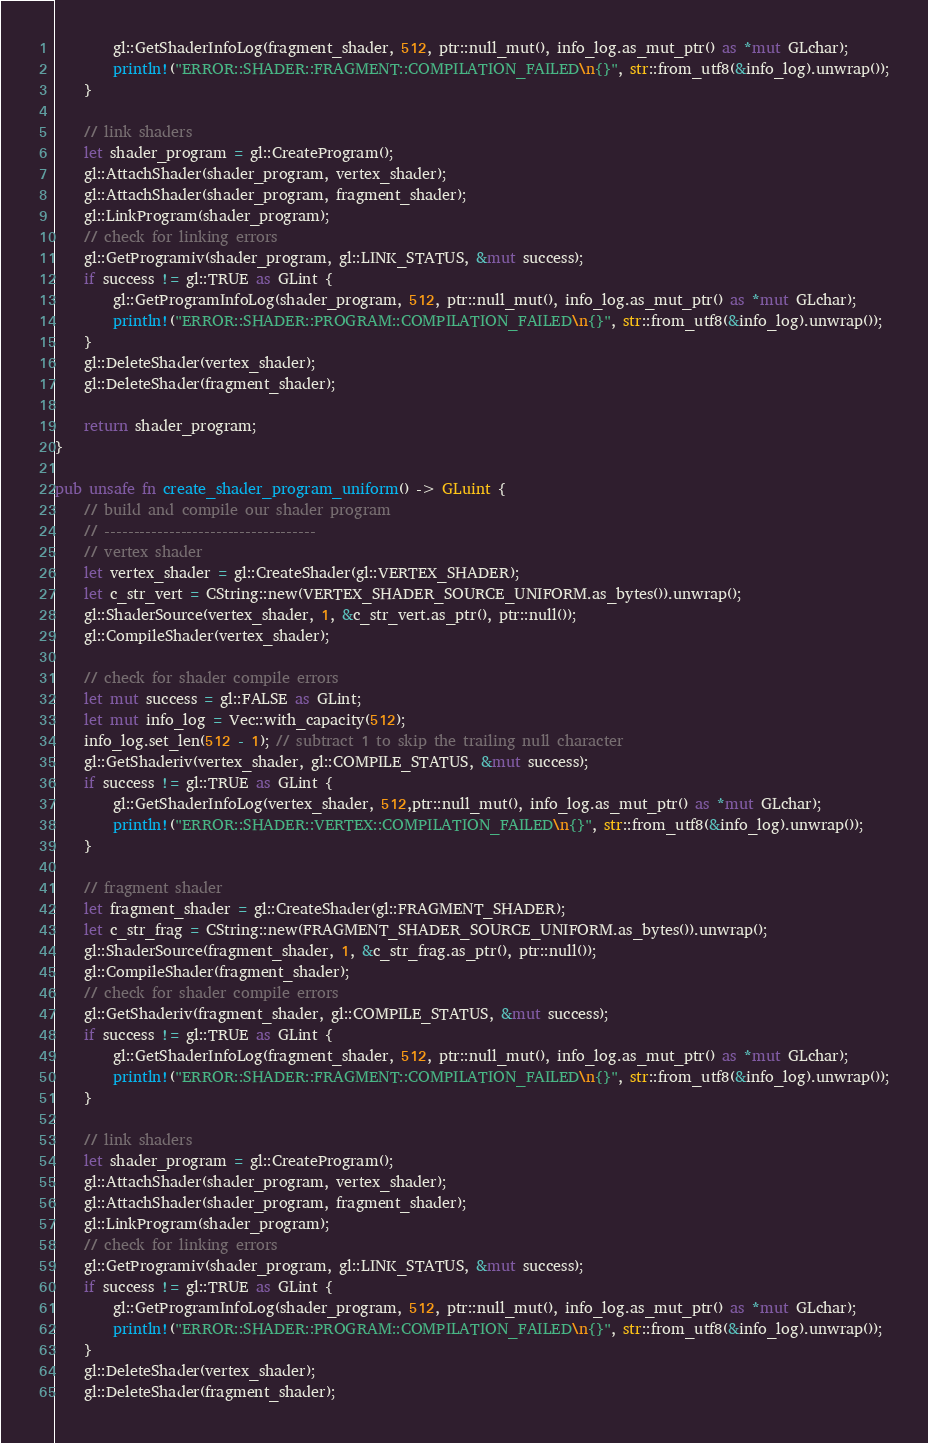<code> <loc_0><loc_0><loc_500><loc_500><_Rust_>        gl::GetShaderInfoLog(fragment_shader, 512, ptr::null_mut(), info_log.as_mut_ptr() as *mut GLchar);
        println!("ERROR::SHADER::FRAGMENT::COMPILATION_FAILED\n{}", str::from_utf8(&info_log).unwrap());
    }

    // link shaders
    let shader_program = gl::CreateProgram();
    gl::AttachShader(shader_program, vertex_shader);
    gl::AttachShader(shader_program, fragment_shader);
    gl::LinkProgram(shader_program);
    // check for linking errors
    gl::GetProgramiv(shader_program, gl::LINK_STATUS, &mut success);
    if success != gl::TRUE as GLint {
        gl::GetProgramInfoLog(shader_program, 512, ptr::null_mut(), info_log.as_mut_ptr() as *mut GLchar);
        println!("ERROR::SHADER::PROGRAM::COMPILATION_FAILED\n{}", str::from_utf8(&info_log).unwrap());
    }
    gl::DeleteShader(vertex_shader);
    gl::DeleteShader(fragment_shader);

    return shader_program;
}

pub unsafe fn create_shader_program_uniform() -> GLuint {
    // build and compile our shader program
    // ------------------------------------
    // vertex shader
    let vertex_shader = gl::CreateShader(gl::VERTEX_SHADER);
    let c_str_vert = CString::new(VERTEX_SHADER_SOURCE_UNIFORM.as_bytes()).unwrap();
    gl::ShaderSource(vertex_shader, 1, &c_str_vert.as_ptr(), ptr::null());
    gl::CompileShader(vertex_shader);

    // check for shader compile errors
    let mut success = gl::FALSE as GLint;
    let mut info_log = Vec::with_capacity(512);
    info_log.set_len(512 - 1); // subtract 1 to skip the trailing null character
    gl::GetShaderiv(vertex_shader, gl::COMPILE_STATUS, &mut success);
    if success != gl::TRUE as GLint {
        gl::GetShaderInfoLog(vertex_shader, 512,ptr::null_mut(), info_log.as_mut_ptr() as *mut GLchar);
        println!("ERROR::SHADER::VERTEX::COMPILATION_FAILED\n{}", str::from_utf8(&info_log).unwrap());
    }

    // fragment shader
    let fragment_shader = gl::CreateShader(gl::FRAGMENT_SHADER);
    let c_str_frag = CString::new(FRAGMENT_SHADER_SOURCE_UNIFORM.as_bytes()).unwrap();
    gl::ShaderSource(fragment_shader, 1, &c_str_frag.as_ptr(), ptr::null());
    gl::CompileShader(fragment_shader);
    // check for shader compile errors
    gl::GetShaderiv(fragment_shader, gl::COMPILE_STATUS, &mut success);
    if success != gl::TRUE as GLint {
        gl::GetShaderInfoLog(fragment_shader, 512, ptr::null_mut(), info_log.as_mut_ptr() as *mut GLchar);
        println!("ERROR::SHADER::FRAGMENT::COMPILATION_FAILED\n{}", str::from_utf8(&info_log).unwrap());
    }

    // link shaders
    let shader_program = gl::CreateProgram();
    gl::AttachShader(shader_program, vertex_shader);
    gl::AttachShader(shader_program, fragment_shader);
    gl::LinkProgram(shader_program);
    // check for linking errors
    gl::GetProgramiv(shader_program, gl::LINK_STATUS, &mut success);
    if success != gl::TRUE as GLint {
        gl::GetProgramInfoLog(shader_program, 512, ptr::null_mut(), info_log.as_mut_ptr() as *mut GLchar);
        println!("ERROR::SHADER::PROGRAM::COMPILATION_FAILED\n{}", str::from_utf8(&info_log).unwrap());
    }
    gl::DeleteShader(vertex_shader);
    gl::DeleteShader(fragment_shader);
</code> 